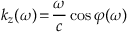<formula> <loc_0><loc_0><loc_500><loc_500>k _ { z } ( \omega ) \, = \, \frac { \omega } { c } \cos { \varphi ( \omega ) }</formula> 